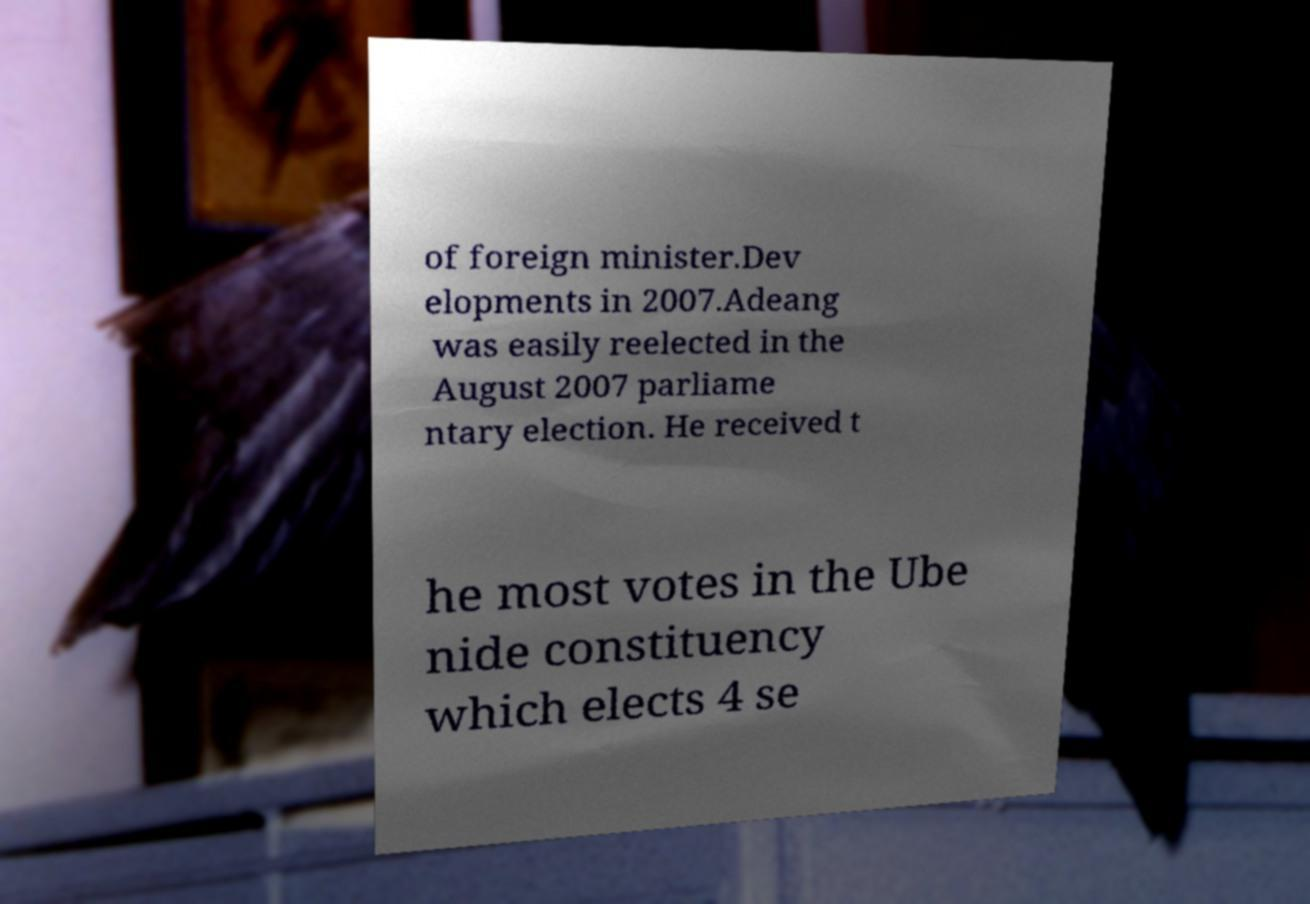Please identify and transcribe the text found in this image. of foreign minister.Dev elopments in 2007.Adeang was easily reelected in the August 2007 parliame ntary election. He received t he most votes in the Ube nide constituency which elects 4 se 